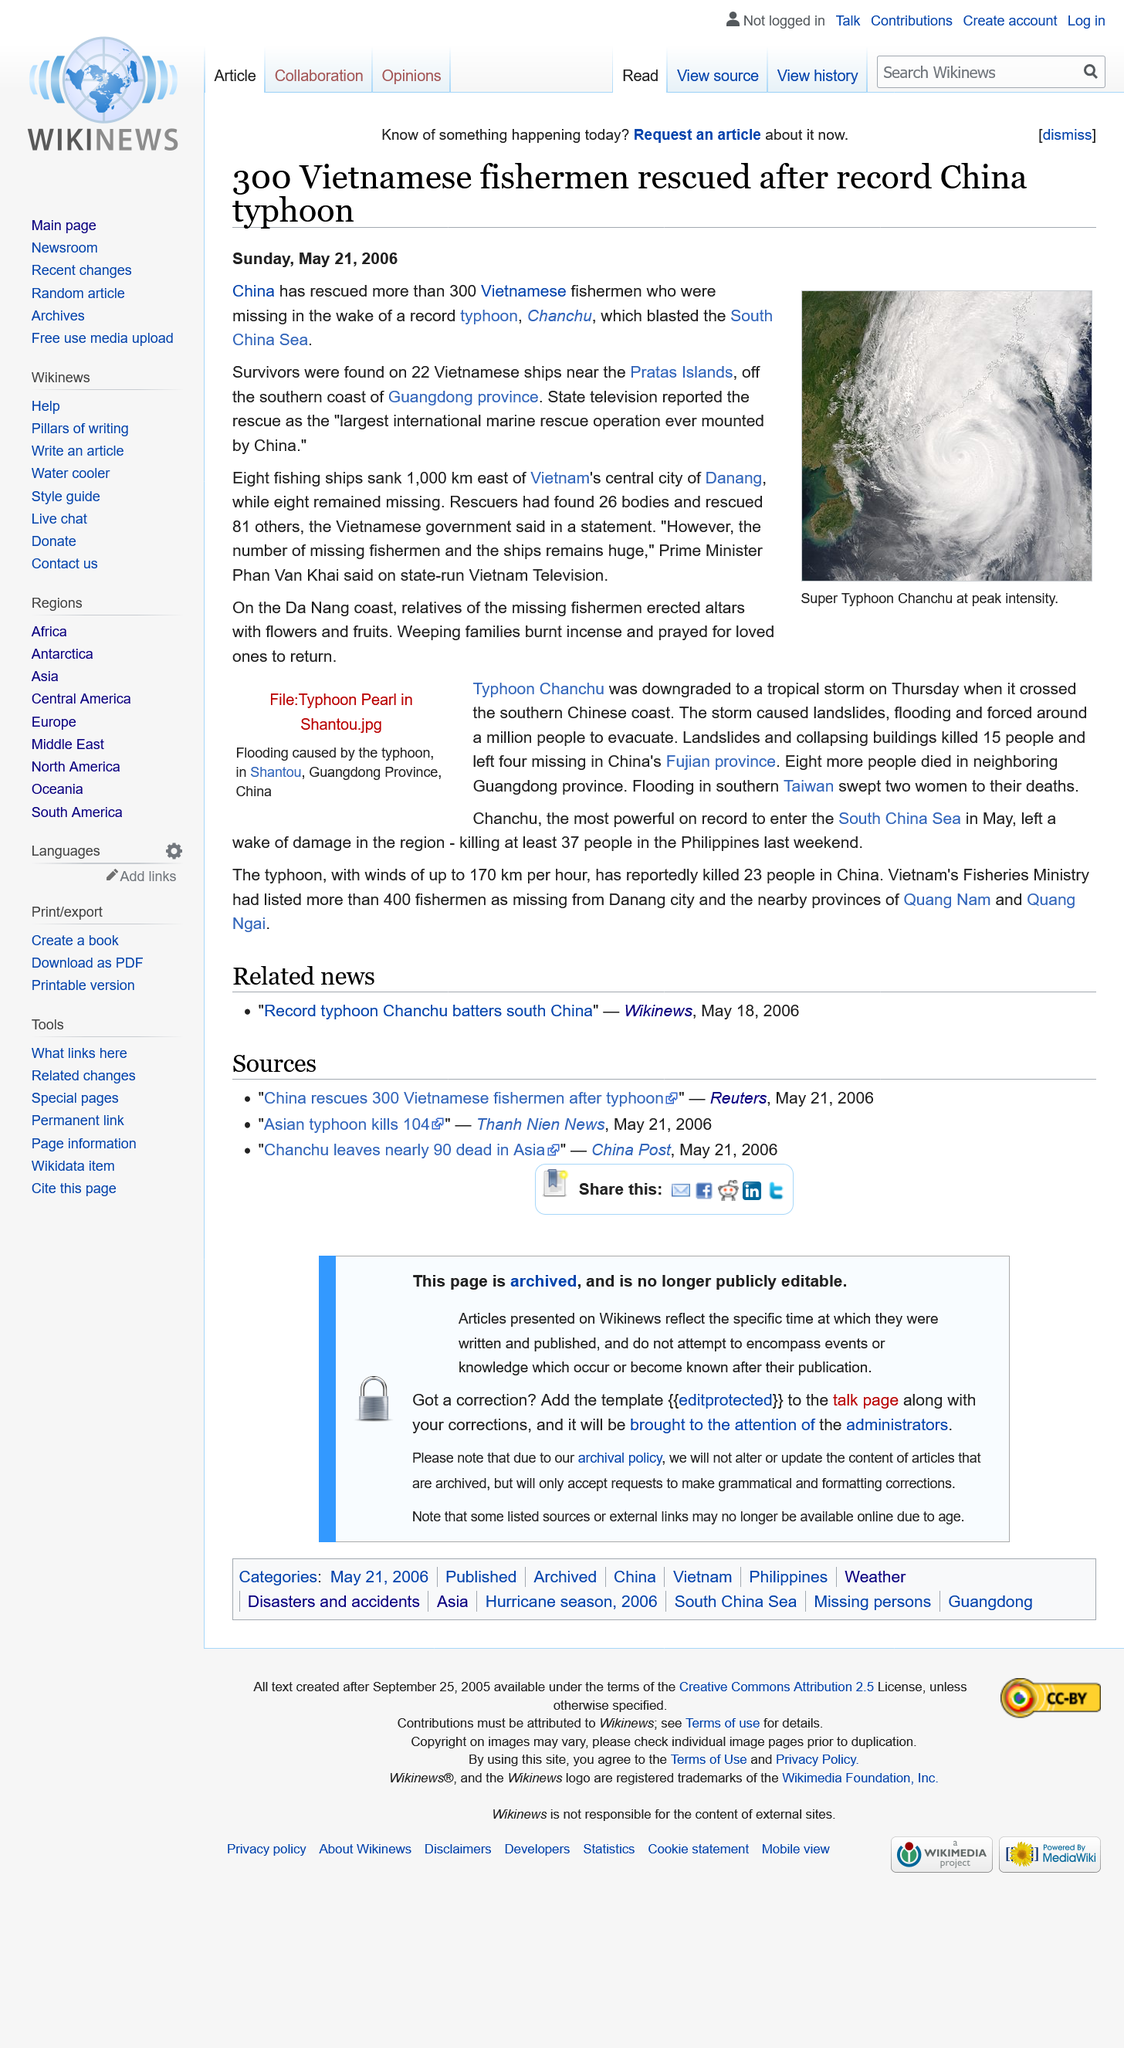Give some essential details in this illustration. At least 300 Vietnamese fishermen were rescued in the recent incident. The survivors were discovered in the vicinity of the Pratas Islands, which are situated approximately 120 nautical miles south of the Guangdong province coastline. State television reported the rescue as the largest international marine rescue operation mounted by China, which was considered as a great achievement by the country. 